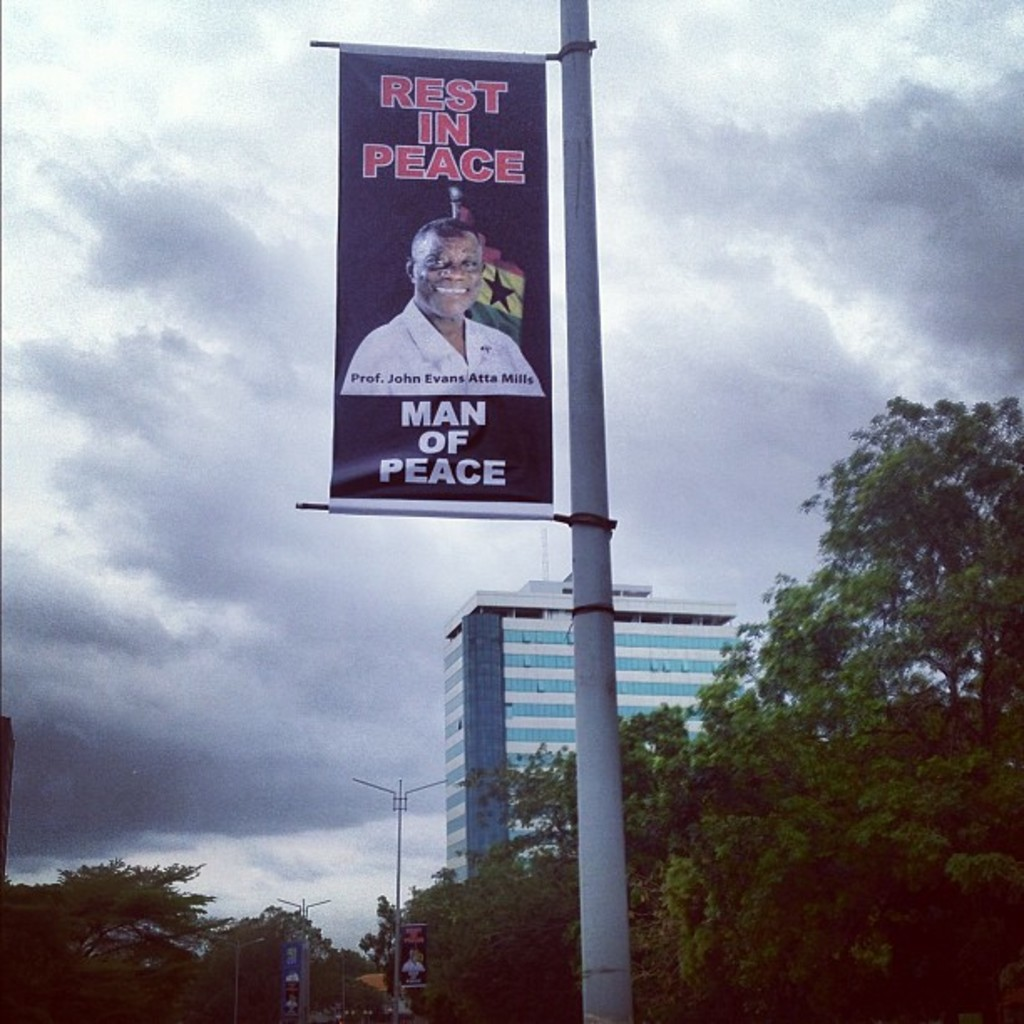What is the significance of displaying this banner in a public space? Displaying such banners in public spaces serves not only as a tribute to the deceased but also as a public acknowledgment of their contributions. It helps in fostering a collective memory and serves as a reminder of the values and principles they stood for, encouraging the community to aspire to these ideals. How does the public typically react to such memorials? Public reactions to such memorials are generally respectful and reflective. They often provoke communal mourning and remembrance, as well as discussions about the individual's legacy and the impact they had on society. Such memorials can strengthen community bonds and highlight shared values. 